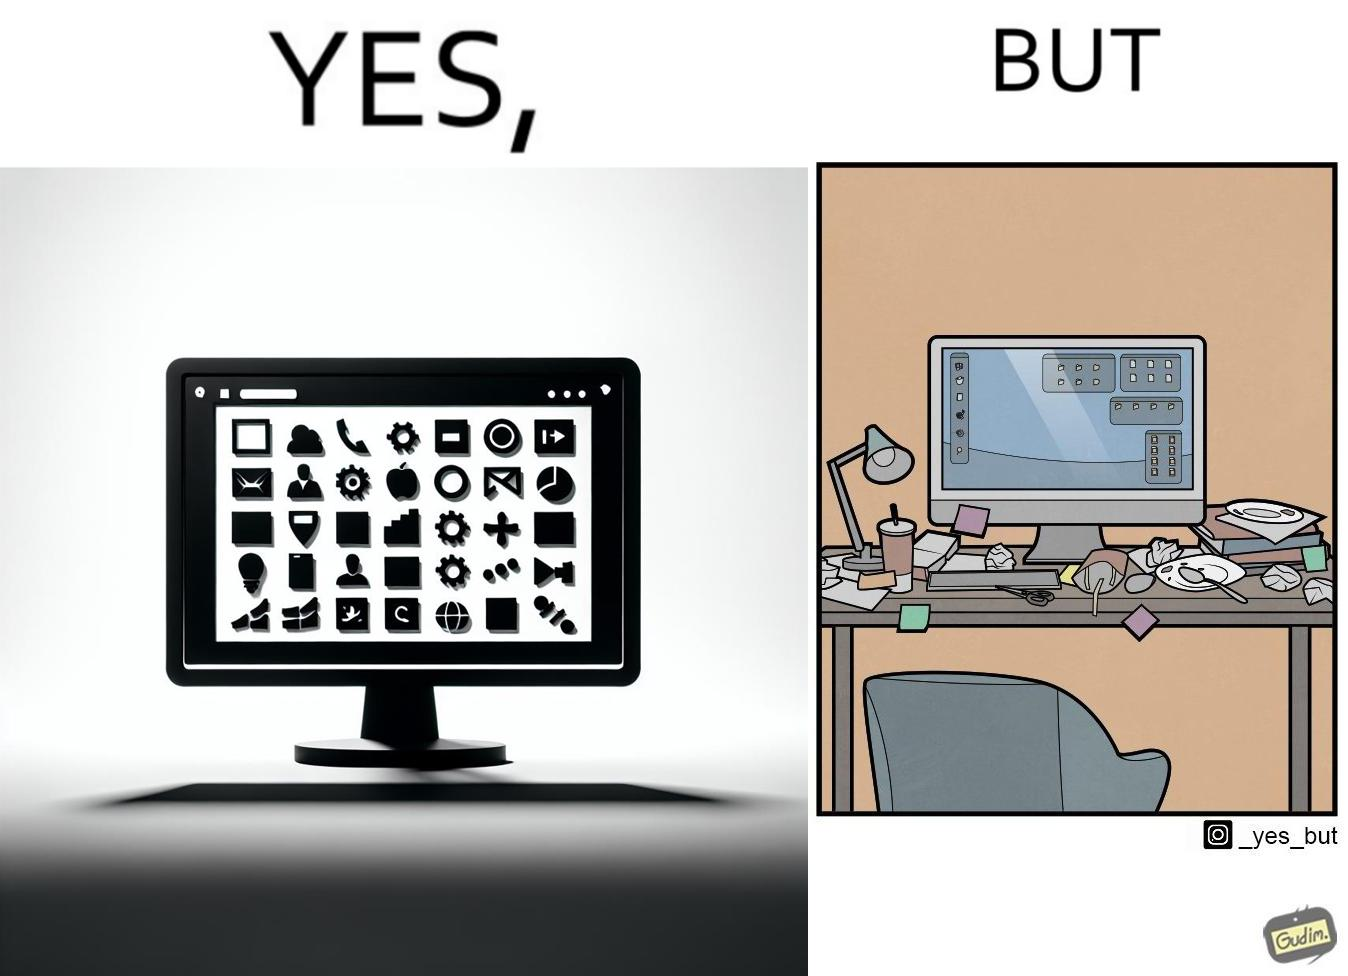What does this image depict? The image is ironical, as the folder icons on the desktop screen are very neatly arranged, while the person using the computer has littered the table with used food packets, dirty plates, and wrappers. 